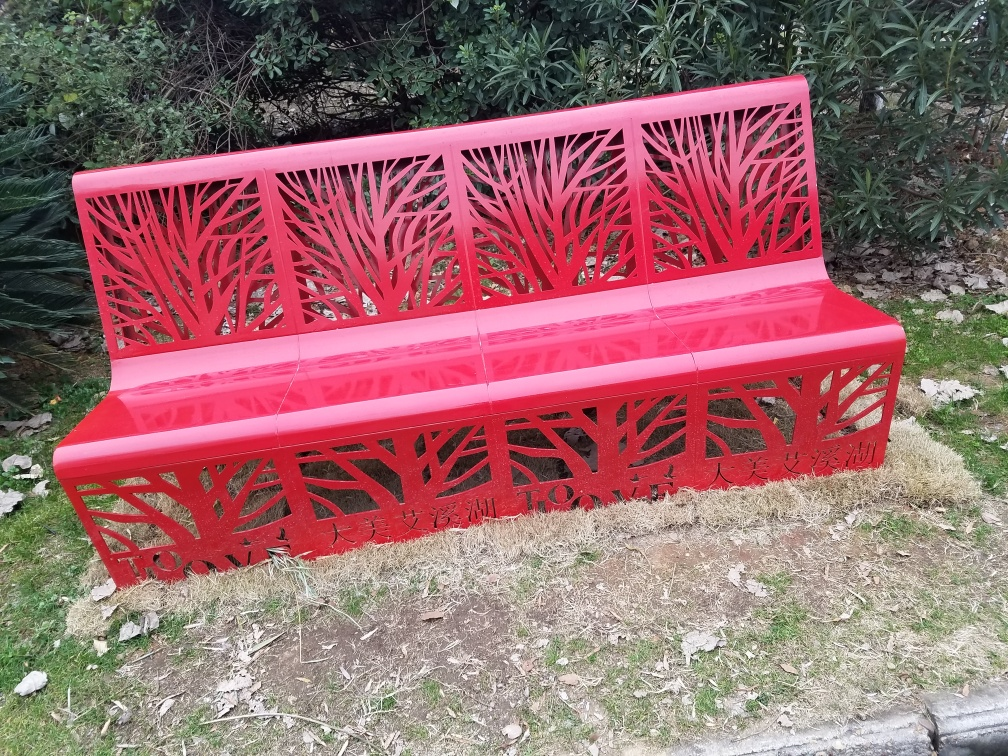What materials is the bench likely made from? The bench appears to be made from metal, which is evident from its clean edges and sturdy structure. The metal is probably treated with a weather-resistant coating in a distinctive red color to withstand outdoor conditions and maintain its vibrant appearance. 